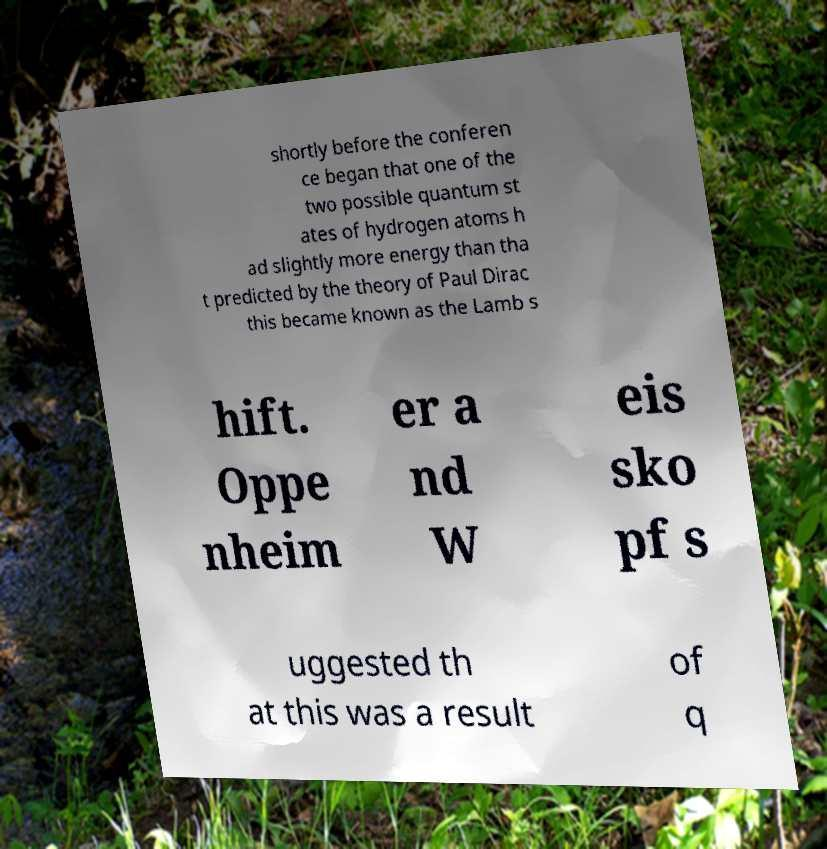There's text embedded in this image that I need extracted. Can you transcribe it verbatim? shortly before the conferen ce began that one of the two possible quantum st ates of hydrogen atoms h ad slightly more energy than tha t predicted by the theory of Paul Dirac this became known as the Lamb s hift. Oppe nheim er a nd W eis sko pf s uggested th at this was a result of q 